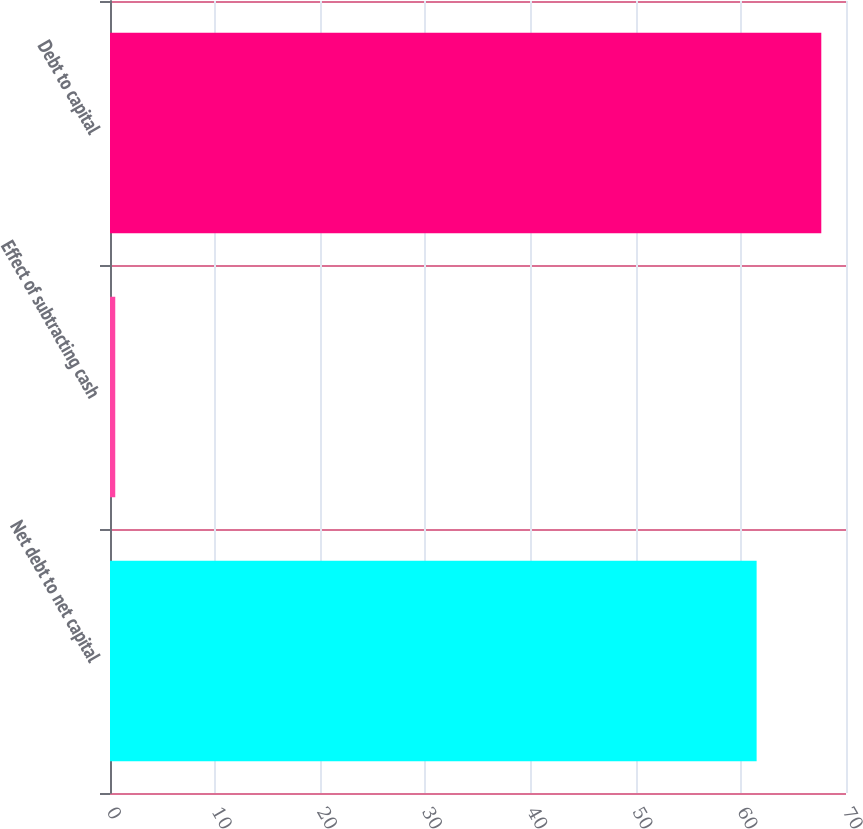Convert chart to OTSL. <chart><loc_0><loc_0><loc_500><loc_500><bar_chart><fcel>Net debt to net capital<fcel>Effect of subtracting cash<fcel>Debt to capital<nl><fcel>61.5<fcel>0.5<fcel>67.65<nl></chart> 